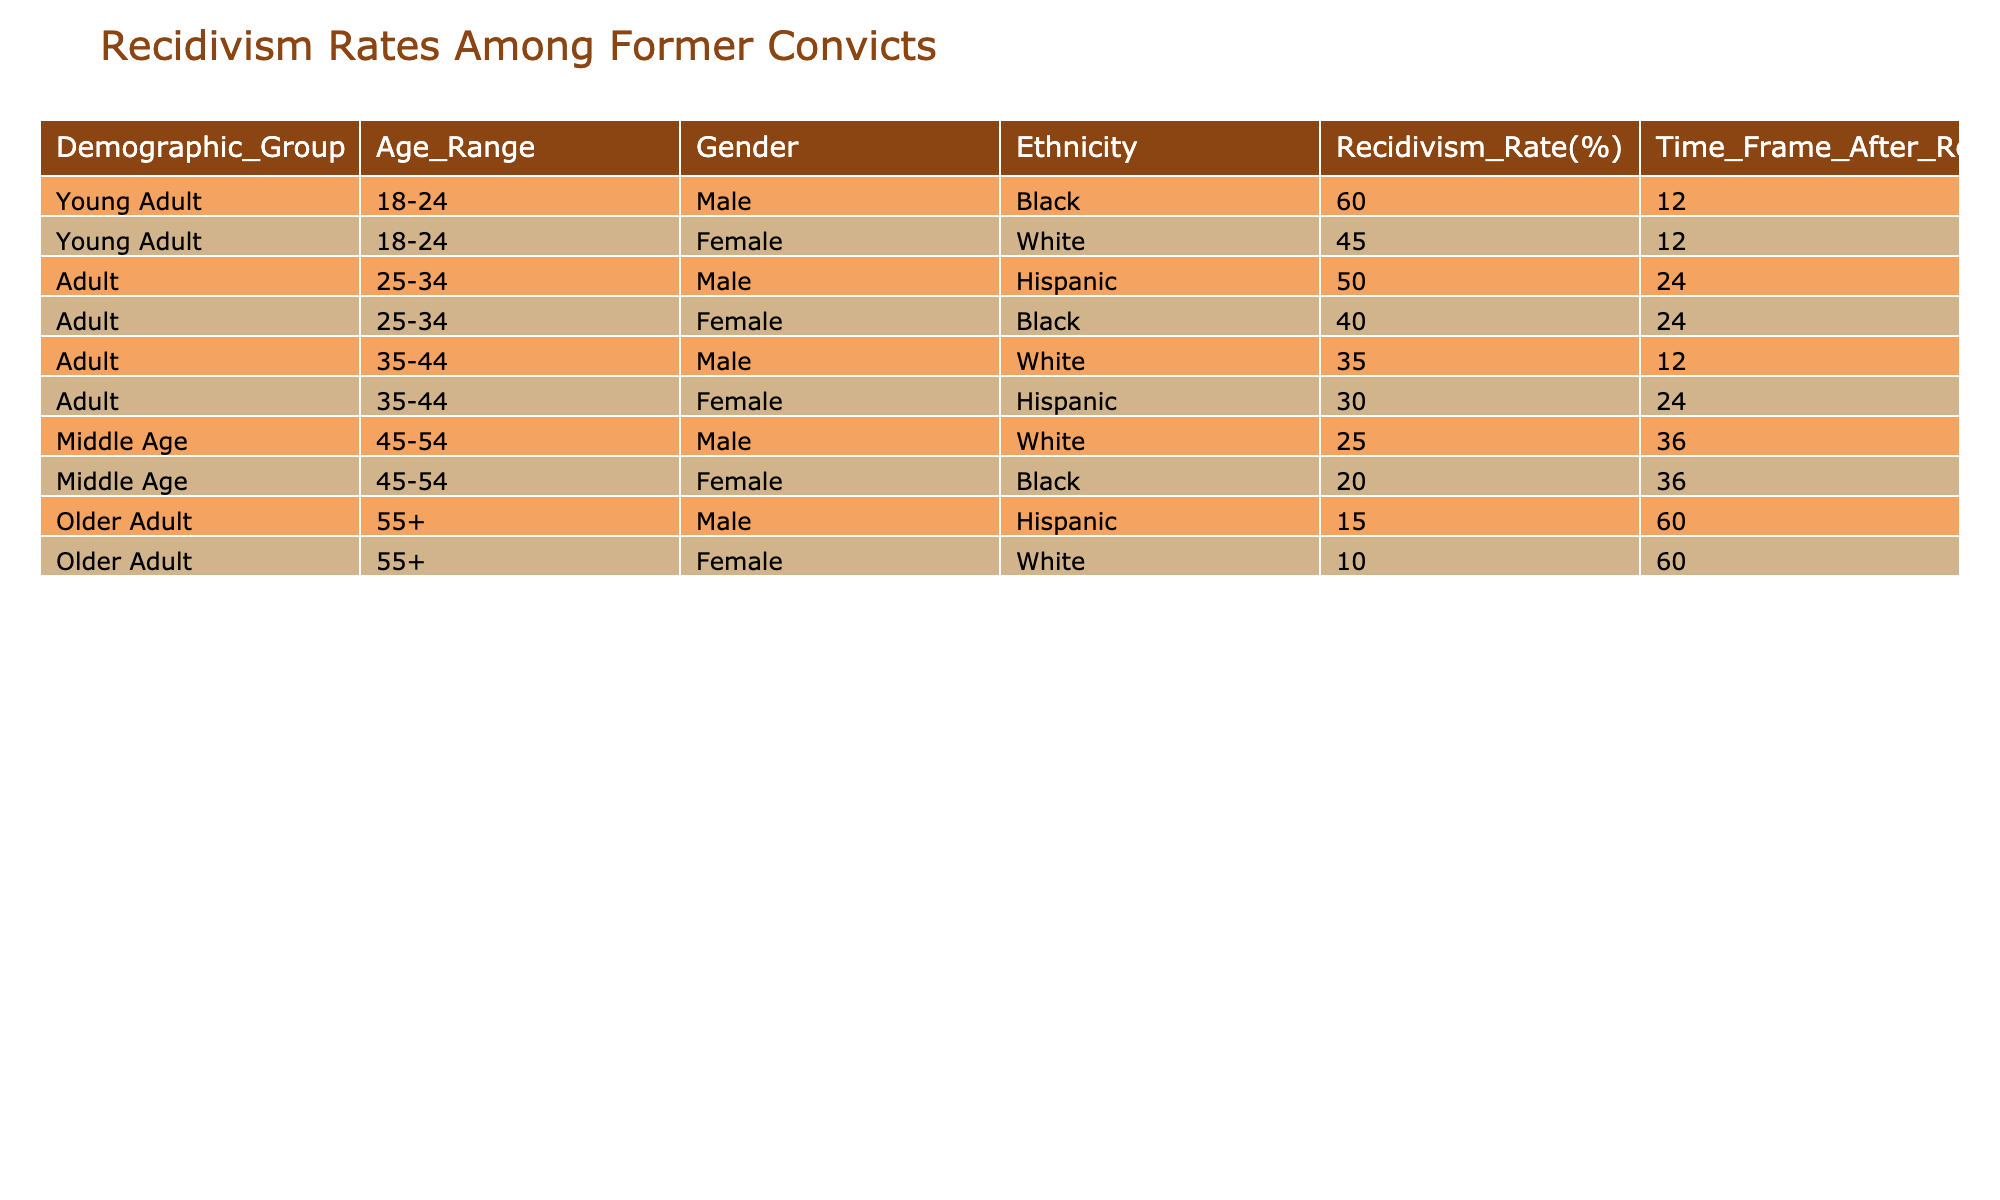What is the recidivism rate for young adult males aged 18-24? According to the table, the recidivism rate for young adult males aged 18-24 is directly listed as 60%.
Answer: 60% What percentage of older adult females aged 55 and above reoffend? The table indicates that the recidivism rate for older adult females aged 55 and above is 10%.
Answer: 10% Which demographic group has the highest recidivism rate? By examining the recidivism rates in the table, the highest rate is 60% for young adult black males aged 18-24.
Answer: Young adult black males aged 18-24 Is the recidivism rate for middle-aged black females lower than that for young adult white females? The table shows that middle-aged black females have a recidivism rate of 20%, while young adult white females have a rate of 45%. Since 20% is lower than 45%, the answer is yes.
Answer: Yes What is the average recidivism rate for adult males across all listed age ranges? To find the average, we first identify all adult male recidivism rates: 50% (25-34) + 35% (35-44) = 85%. There are two groups, thus the average is 85% divided by 2, which equals 42.5%.
Answer: 42.5% Which ethnic group has the lowest recidivism rate among older adults? The table shows that the recidivism rates for older adults are 15% for Hispanic males and 10% for white females. Thus, the lowest rate is for older adult white females at 10%.
Answer: Older adult white females Are the recidivism rates for Hispanic males and females aged 35-44 the same? According to the table, Hispanic males aged 35-44 have a recidivism rate of 30%, while no data is provided for Hispanic females in that age range, so we do not have comparable data to determine if the rates are the same.
Answer: No What is the total recidivism rate for young adults (both genders) after 12 months? We sum the recidivism rates for young adult males (60%) and young adult females (45%), resulting in a total of 105%. Since there are two groups, the average rate would be 105% divided by 2, which equals 52.5%.
Answer: 52.5% Which age range has the lowest overall recidivism rates for both genders? By reviewing the rates across all age ranges in the table, the lowest overall rates belong to older adults (15% for males and 10% for females), making this age range the demographic with the lowest rates.
Answer: Older adults 